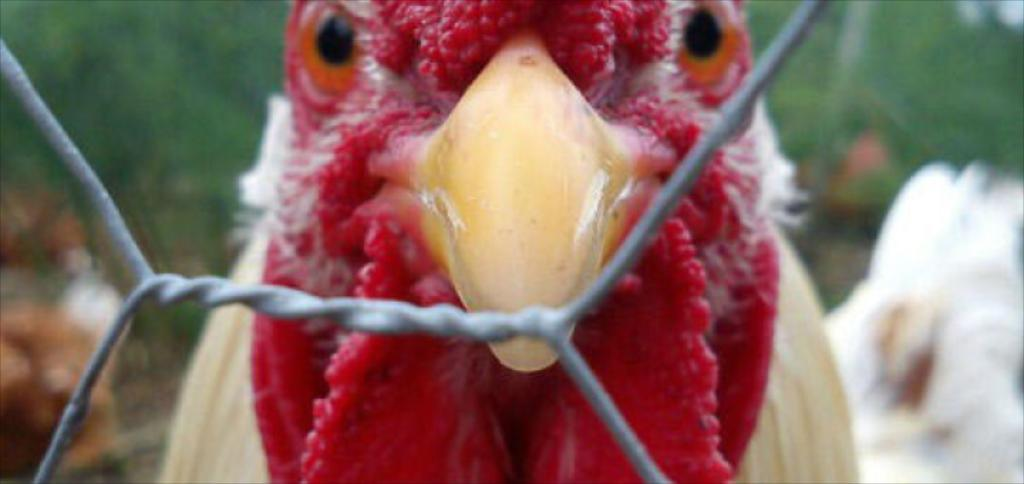What animal is present in the image? There is a hen in the image. What object can be seen in the image besides the hen? There is a wire in the image. Can you describe the background of the image? The background of the image is blurred. How many pizzas are being served on the patch in the image? There are no pizzas or patches present in the image; it features a hen and a wire. What type of glass is being used to hold the hen in the image? There is no glass present in the image; the hen is not contained in any glass object. 